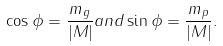<formula> <loc_0><loc_0><loc_500><loc_500>\cos \phi = \frac { m _ { g } } { | M | } a n d \sin \phi = \frac { m _ { p } } { | M | } .</formula> 